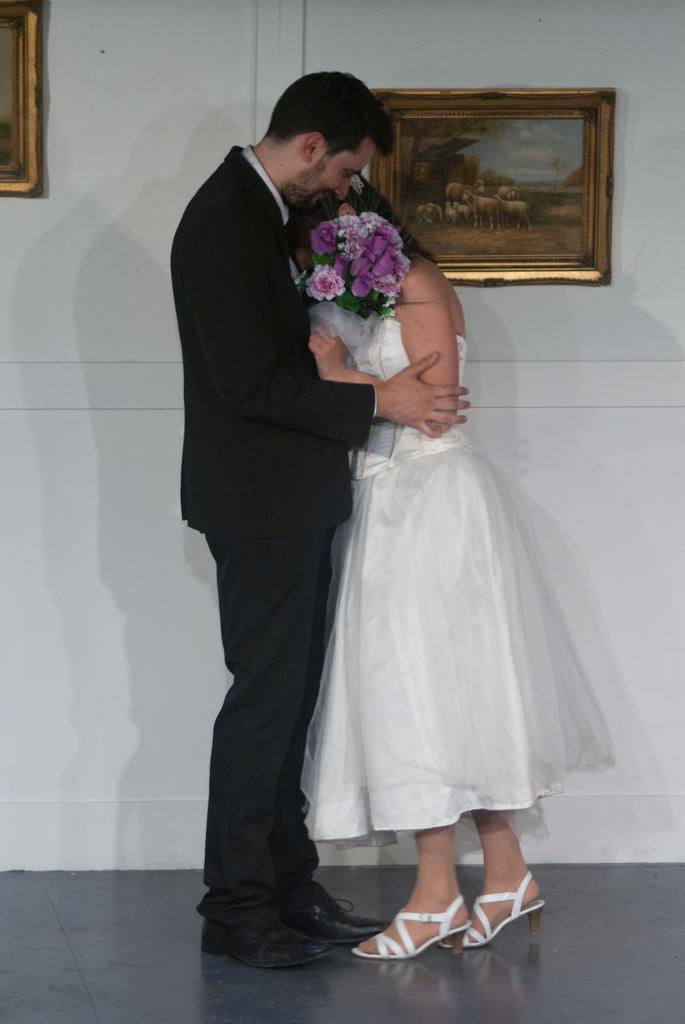Who is present in the image? There is a couple in the image. What are the couple doing in the image? The couple is standing. What object is present between the couple? There is a bouquet between the couple. What can be seen on the wall in the background? There are two photo frames on the wall in the background. What type of berry is rolling on the floor in the image? There is no berry present in the image, and the floor is not mentioned in the provided facts. 